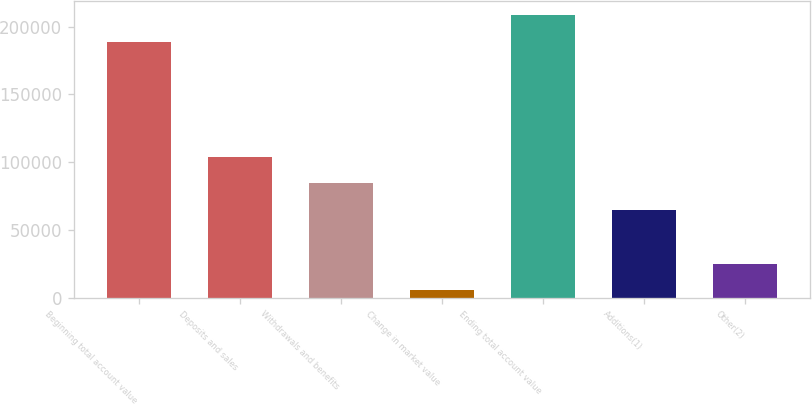<chart> <loc_0><loc_0><loc_500><loc_500><bar_chart><fcel>Beginning total account value<fcel>Deposits and sales<fcel>Withdrawals and benefits<fcel>Change in market value<fcel>Ending total account value<fcel>Additions(1)<fcel>Other(2)<nl><fcel>188961<fcel>104050<fcel>84300.2<fcel>5299<fcel>208711<fcel>64549.9<fcel>25049.3<nl></chart> 